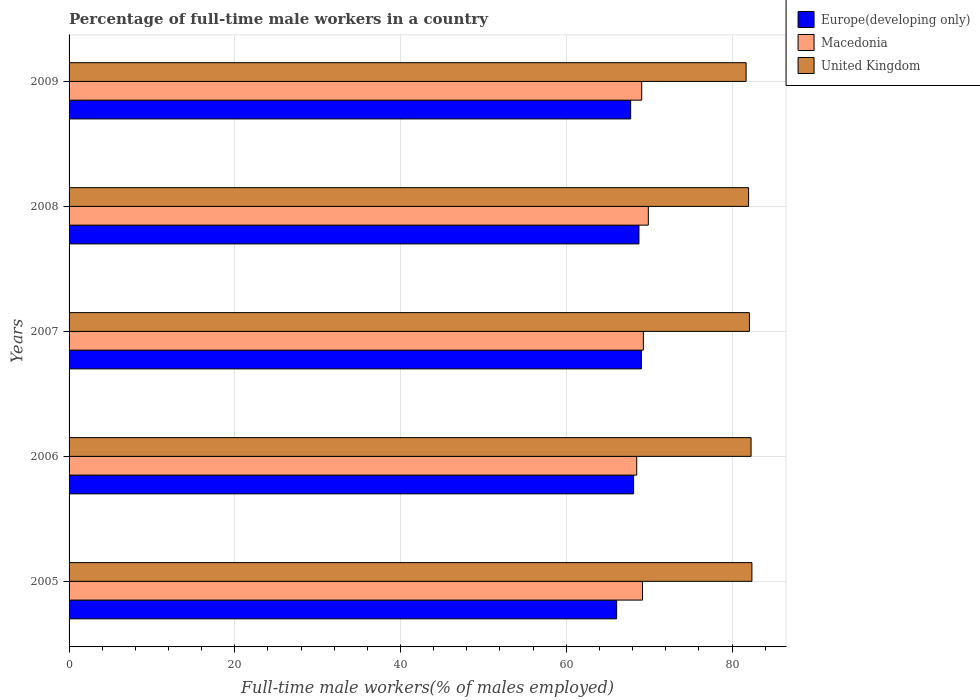How many groups of bars are there?
Provide a succinct answer. 5. Are the number of bars per tick equal to the number of legend labels?
Provide a short and direct response. Yes. What is the label of the 5th group of bars from the top?
Your answer should be very brief. 2005. What is the percentage of full-time male workers in United Kingdom in 2006?
Keep it short and to the point. 82.3. Across all years, what is the maximum percentage of full-time male workers in Macedonia?
Your answer should be compact. 69.9. Across all years, what is the minimum percentage of full-time male workers in Macedonia?
Keep it short and to the point. 68.5. In which year was the percentage of full-time male workers in Macedonia minimum?
Ensure brevity in your answer.  2006. What is the total percentage of full-time male workers in United Kingdom in the graph?
Provide a succinct answer. 410.5. What is the difference between the percentage of full-time male workers in Europe(developing only) in 2006 and that in 2007?
Keep it short and to the point. -0.93. What is the difference between the percentage of full-time male workers in Europe(developing only) in 2005 and the percentage of full-time male workers in Macedonia in 2008?
Offer a very short reply. -3.82. What is the average percentage of full-time male workers in United Kingdom per year?
Give a very brief answer. 82.1. In the year 2007, what is the difference between the percentage of full-time male workers in Macedonia and percentage of full-time male workers in Europe(developing only)?
Ensure brevity in your answer.  0.24. What is the ratio of the percentage of full-time male workers in United Kingdom in 2007 to that in 2009?
Offer a terse response. 1. Is the difference between the percentage of full-time male workers in Macedonia in 2007 and 2009 greater than the difference between the percentage of full-time male workers in Europe(developing only) in 2007 and 2009?
Provide a short and direct response. No. What is the difference between the highest and the second highest percentage of full-time male workers in Macedonia?
Your answer should be compact. 0.6. What is the difference between the highest and the lowest percentage of full-time male workers in Europe(developing only)?
Provide a succinct answer. 2.98. Is the sum of the percentage of full-time male workers in Europe(developing only) in 2006 and 2009 greater than the maximum percentage of full-time male workers in Macedonia across all years?
Make the answer very short. Yes. What does the 2nd bar from the top in 2006 represents?
Provide a succinct answer. Macedonia. What does the 3rd bar from the bottom in 2009 represents?
Ensure brevity in your answer.  United Kingdom. How many bars are there?
Offer a terse response. 15. Are all the bars in the graph horizontal?
Your answer should be compact. Yes. What is the difference between two consecutive major ticks on the X-axis?
Provide a succinct answer. 20. Does the graph contain grids?
Provide a short and direct response. Yes. Where does the legend appear in the graph?
Keep it short and to the point. Top right. How are the legend labels stacked?
Provide a short and direct response. Vertical. What is the title of the graph?
Make the answer very short. Percentage of full-time male workers in a country. Does "Vanuatu" appear as one of the legend labels in the graph?
Keep it short and to the point. No. What is the label or title of the X-axis?
Make the answer very short. Full-time male workers(% of males employed). What is the Full-time male workers(% of males employed) of Europe(developing only) in 2005?
Give a very brief answer. 66.08. What is the Full-time male workers(% of males employed) of Macedonia in 2005?
Offer a very short reply. 69.2. What is the Full-time male workers(% of males employed) of United Kingdom in 2005?
Keep it short and to the point. 82.4. What is the Full-time male workers(% of males employed) in Europe(developing only) in 2006?
Keep it short and to the point. 68.12. What is the Full-time male workers(% of males employed) of Macedonia in 2006?
Keep it short and to the point. 68.5. What is the Full-time male workers(% of males employed) of United Kingdom in 2006?
Your response must be concise. 82.3. What is the Full-time male workers(% of males employed) in Europe(developing only) in 2007?
Offer a very short reply. 69.06. What is the Full-time male workers(% of males employed) of Macedonia in 2007?
Make the answer very short. 69.3. What is the Full-time male workers(% of males employed) in United Kingdom in 2007?
Offer a terse response. 82.1. What is the Full-time male workers(% of males employed) in Europe(developing only) in 2008?
Give a very brief answer. 68.77. What is the Full-time male workers(% of males employed) of Macedonia in 2008?
Provide a short and direct response. 69.9. What is the Full-time male workers(% of males employed) in United Kingdom in 2008?
Keep it short and to the point. 82. What is the Full-time male workers(% of males employed) of Europe(developing only) in 2009?
Provide a short and direct response. 67.77. What is the Full-time male workers(% of males employed) in Macedonia in 2009?
Your answer should be very brief. 69.1. What is the Full-time male workers(% of males employed) in United Kingdom in 2009?
Your answer should be compact. 81.7. Across all years, what is the maximum Full-time male workers(% of males employed) in Europe(developing only)?
Give a very brief answer. 69.06. Across all years, what is the maximum Full-time male workers(% of males employed) of Macedonia?
Ensure brevity in your answer.  69.9. Across all years, what is the maximum Full-time male workers(% of males employed) of United Kingdom?
Provide a succinct answer. 82.4. Across all years, what is the minimum Full-time male workers(% of males employed) in Europe(developing only)?
Keep it short and to the point. 66.08. Across all years, what is the minimum Full-time male workers(% of males employed) of Macedonia?
Your response must be concise. 68.5. Across all years, what is the minimum Full-time male workers(% of males employed) of United Kingdom?
Offer a very short reply. 81.7. What is the total Full-time male workers(% of males employed) of Europe(developing only) in the graph?
Offer a very short reply. 339.8. What is the total Full-time male workers(% of males employed) in Macedonia in the graph?
Ensure brevity in your answer.  346. What is the total Full-time male workers(% of males employed) of United Kingdom in the graph?
Offer a terse response. 410.5. What is the difference between the Full-time male workers(% of males employed) in Europe(developing only) in 2005 and that in 2006?
Provide a short and direct response. -2.05. What is the difference between the Full-time male workers(% of males employed) in Europe(developing only) in 2005 and that in 2007?
Make the answer very short. -2.98. What is the difference between the Full-time male workers(% of males employed) of Macedonia in 2005 and that in 2007?
Your answer should be very brief. -0.1. What is the difference between the Full-time male workers(% of males employed) of Europe(developing only) in 2005 and that in 2008?
Keep it short and to the point. -2.69. What is the difference between the Full-time male workers(% of males employed) of United Kingdom in 2005 and that in 2008?
Give a very brief answer. 0.4. What is the difference between the Full-time male workers(% of males employed) of Europe(developing only) in 2005 and that in 2009?
Provide a short and direct response. -1.69. What is the difference between the Full-time male workers(% of males employed) in Europe(developing only) in 2006 and that in 2007?
Make the answer very short. -0.93. What is the difference between the Full-time male workers(% of males employed) in Macedonia in 2006 and that in 2007?
Offer a terse response. -0.8. What is the difference between the Full-time male workers(% of males employed) in Europe(developing only) in 2006 and that in 2008?
Your answer should be compact. -0.64. What is the difference between the Full-time male workers(% of males employed) in Europe(developing only) in 2006 and that in 2009?
Offer a terse response. 0.36. What is the difference between the Full-time male workers(% of males employed) of Macedonia in 2006 and that in 2009?
Provide a short and direct response. -0.6. What is the difference between the Full-time male workers(% of males employed) of Europe(developing only) in 2007 and that in 2008?
Offer a very short reply. 0.29. What is the difference between the Full-time male workers(% of males employed) of United Kingdom in 2007 and that in 2008?
Keep it short and to the point. 0.1. What is the difference between the Full-time male workers(% of males employed) in Europe(developing only) in 2007 and that in 2009?
Ensure brevity in your answer.  1.29. What is the difference between the Full-time male workers(% of males employed) in Macedonia in 2007 and that in 2009?
Your answer should be very brief. 0.2. What is the difference between the Full-time male workers(% of males employed) in Europe(developing only) in 2005 and the Full-time male workers(% of males employed) in Macedonia in 2006?
Your answer should be compact. -2.42. What is the difference between the Full-time male workers(% of males employed) in Europe(developing only) in 2005 and the Full-time male workers(% of males employed) in United Kingdom in 2006?
Ensure brevity in your answer.  -16.22. What is the difference between the Full-time male workers(% of males employed) in Macedonia in 2005 and the Full-time male workers(% of males employed) in United Kingdom in 2006?
Give a very brief answer. -13.1. What is the difference between the Full-time male workers(% of males employed) in Europe(developing only) in 2005 and the Full-time male workers(% of males employed) in Macedonia in 2007?
Provide a succinct answer. -3.22. What is the difference between the Full-time male workers(% of males employed) of Europe(developing only) in 2005 and the Full-time male workers(% of males employed) of United Kingdom in 2007?
Offer a very short reply. -16.02. What is the difference between the Full-time male workers(% of males employed) in Europe(developing only) in 2005 and the Full-time male workers(% of males employed) in Macedonia in 2008?
Make the answer very short. -3.82. What is the difference between the Full-time male workers(% of males employed) in Europe(developing only) in 2005 and the Full-time male workers(% of males employed) in United Kingdom in 2008?
Provide a succinct answer. -15.92. What is the difference between the Full-time male workers(% of males employed) in Macedonia in 2005 and the Full-time male workers(% of males employed) in United Kingdom in 2008?
Make the answer very short. -12.8. What is the difference between the Full-time male workers(% of males employed) of Europe(developing only) in 2005 and the Full-time male workers(% of males employed) of Macedonia in 2009?
Offer a very short reply. -3.02. What is the difference between the Full-time male workers(% of males employed) of Europe(developing only) in 2005 and the Full-time male workers(% of males employed) of United Kingdom in 2009?
Provide a succinct answer. -15.62. What is the difference between the Full-time male workers(% of males employed) of Macedonia in 2005 and the Full-time male workers(% of males employed) of United Kingdom in 2009?
Make the answer very short. -12.5. What is the difference between the Full-time male workers(% of males employed) in Europe(developing only) in 2006 and the Full-time male workers(% of males employed) in Macedonia in 2007?
Provide a succinct answer. -1.18. What is the difference between the Full-time male workers(% of males employed) of Europe(developing only) in 2006 and the Full-time male workers(% of males employed) of United Kingdom in 2007?
Offer a very short reply. -13.98. What is the difference between the Full-time male workers(% of males employed) in Europe(developing only) in 2006 and the Full-time male workers(% of males employed) in Macedonia in 2008?
Provide a short and direct response. -1.78. What is the difference between the Full-time male workers(% of males employed) of Europe(developing only) in 2006 and the Full-time male workers(% of males employed) of United Kingdom in 2008?
Keep it short and to the point. -13.88. What is the difference between the Full-time male workers(% of males employed) in Macedonia in 2006 and the Full-time male workers(% of males employed) in United Kingdom in 2008?
Offer a terse response. -13.5. What is the difference between the Full-time male workers(% of males employed) of Europe(developing only) in 2006 and the Full-time male workers(% of males employed) of Macedonia in 2009?
Give a very brief answer. -0.98. What is the difference between the Full-time male workers(% of males employed) in Europe(developing only) in 2006 and the Full-time male workers(% of males employed) in United Kingdom in 2009?
Provide a succinct answer. -13.58. What is the difference between the Full-time male workers(% of males employed) in Europe(developing only) in 2007 and the Full-time male workers(% of males employed) in Macedonia in 2008?
Provide a succinct answer. -0.84. What is the difference between the Full-time male workers(% of males employed) in Europe(developing only) in 2007 and the Full-time male workers(% of males employed) in United Kingdom in 2008?
Provide a succinct answer. -12.94. What is the difference between the Full-time male workers(% of males employed) in Macedonia in 2007 and the Full-time male workers(% of males employed) in United Kingdom in 2008?
Your answer should be compact. -12.7. What is the difference between the Full-time male workers(% of males employed) of Europe(developing only) in 2007 and the Full-time male workers(% of males employed) of Macedonia in 2009?
Provide a short and direct response. -0.04. What is the difference between the Full-time male workers(% of males employed) of Europe(developing only) in 2007 and the Full-time male workers(% of males employed) of United Kingdom in 2009?
Offer a very short reply. -12.64. What is the difference between the Full-time male workers(% of males employed) of Europe(developing only) in 2008 and the Full-time male workers(% of males employed) of Macedonia in 2009?
Keep it short and to the point. -0.33. What is the difference between the Full-time male workers(% of males employed) in Europe(developing only) in 2008 and the Full-time male workers(% of males employed) in United Kingdom in 2009?
Provide a short and direct response. -12.93. What is the difference between the Full-time male workers(% of males employed) of Macedonia in 2008 and the Full-time male workers(% of males employed) of United Kingdom in 2009?
Ensure brevity in your answer.  -11.8. What is the average Full-time male workers(% of males employed) of Europe(developing only) per year?
Provide a short and direct response. 67.96. What is the average Full-time male workers(% of males employed) in Macedonia per year?
Keep it short and to the point. 69.2. What is the average Full-time male workers(% of males employed) in United Kingdom per year?
Ensure brevity in your answer.  82.1. In the year 2005, what is the difference between the Full-time male workers(% of males employed) in Europe(developing only) and Full-time male workers(% of males employed) in Macedonia?
Give a very brief answer. -3.12. In the year 2005, what is the difference between the Full-time male workers(% of males employed) in Europe(developing only) and Full-time male workers(% of males employed) in United Kingdom?
Offer a terse response. -16.32. In the year 2005, what is the difference between the Full-time male workers(% of males employed) of Macedonia and Full-time male workers(% of males employed) of United Kingdom?
Your answer should be very brief. -13.2. In the year 2006, what is the difference between the Full-time male workers(% of males employed) of Europe(developing only) and Full-time male workers(% of males employed) of Macedonia?
Your answer should be very brief. -0.38. In the year 2006, what is the difference between the Full-time male workers(% of males employed) in Europe(developing only) and Full-time male workers(% of males employed) in United Kingdom?
Offer a very short reply. -14.18. In the year 2007, what is the difference between the Full-time male workers(% of males employed) in Europe(developing only) and Full-time male workers(% of males employed) in Macedonia?
Make the answer very short. -0.24. In the year 2007, what is the difference between the Full-time male workers(% of males employed) of Europe(developing only) and Full-time male workers(% of males employed) of United Kingdom?
Your answer should be very brief. -13.04. In the year 2008, what is the difference between the Full-time male workers(% of males employed) in Europe(developing only) and Full-time male workers(% of males employed) in Macedonia?
Give a very brief answer. -1.13. In the year 2008, what is the difference between the Full-time male workers(% of males employed) in Europe(developing only) and Full-time male workers(% of males employed) in United Kingdom?
Your response must be concise. -13.23. In the year 2008, what is the difference between the Full-time male workers(% of males employed) of Macedonia and Full-time male workers(% of males employed) of United Kingdom?
Your response must be concise. -12.1. In the year 2009, what is the difference between the Full-time male workers(% of males employed) of Europe(developing only) and Full-time male workers(% of males employed) of Macedonia?
Keep it short and to the point. -1.33. In the year 2009, what is the difference between the Full-time male workers(% of males employed) of Europe(developing only) and Full-time male workers(% of males employed) of United Kingdom?
Your answer should be compact. -13.93. In the year 2009, what is the difference between the Full-time male workers(% of males employed) of Macedonia and Full-time male workers(% of males employed) of United Kingdom?
Provide a succinct answer. -12.6. What is the ratio of the Full-time male workers(% of males employed) in Europe(developing only) in 2005 to that in 2006?
Offer a very short reply. 0.97. What is the ratio of the Full-time male workers(% of males employed) of Macedonia in 2005 to that in 2006?
Offer a terse response. 1.01. What is the ratio of the Full-time male workers(% of males employed) of United Kingdom in 2005 to that in 2006?
Your answer should be compact. 1. What is the ratio of the Full-time male workers(% of males employed) in Europe(developing only) in 2005 to that in 2007?
Your response must be concise. 0.96. What is the ratio of the Full-time male workers(% of males employed) of Macedonia in 2005 to that in 2007?
Keep it short and to the point. 1. What is the ratio of the Full-time male workers(% of males employed) in Europe(developing only) in 2005 to that in 2008?
Provide a short and direct response. 0.96. What is the ratio of the Full-time male workers(% of males employed) of Macedonia in 2005 to that in 2008?
Your answer should be very brief. 0.99. What is the ratio of the Full-time male workers(% of males employed) in Europe(developing only) in 2005 to that in 2009?
Offer a very short reply. 0.98. What is the ratio of the Full-time male workers(% of males employed) in Macedonia in 2005 to that in 2009?
Offer a terse response. 1. What is the ratio of the Full-time male workers(% of males employed) in United Kingdom in 2005 to that in 2009?
Offer a terse response. 1.01. What is the ratio of the Full-time male workers(% of males employed) in Europe(developing only) in 2006 to that in 2007?
Provide a short and direct response. 0.99. What is the ratio of the Full-time male workers(% of males employed) of Europe(developing only) in 2006 to that in 2008?
Keep it short and to the point. 0.99. What is the ratio of the Full-time male workers(% of males employed) of Macedonia in 2006 to that in 2008?
Ensure brevity in your answer.  0.98. What is the ratio of the Full-time male workers(% of males employed) in United Kingdom in 2006 to that in 2009?
Give a very brief answer. 1.01. What is the ratio of the Full-time male workers(% of males employed) of Europe(developing only) in 2007 to that in 2008?
Your answer should be very brief. 1. What is the ratio of the Full-time male workers(% of males employed) in Macedonia in 2007 to that in 2008?
Keep it short and to the point. 0.99. What is the ratio of the Full-time male workers(% of males employed) in Europe(developing only) in 2007 to that in 2009?
Offer a terse response. 1.02. What is the ratio of the Full-time male workers(% of males employed) in United Kingdom in 2007 to that in 2009?
Offer a very short reply. 1. What is the ratio of the Full-time male workers(% of males employed) of Europe(developing only) in 2008 to that in 2009?
Keep it short and to the point. 1.01. What is the ratio of the Full-time male workers(% of males employed) in Macedonia in 2008 to that in 2009?
Give a very brief answer. 1.01. What is the ratio of the Full-time male workers(% of males employed) of United Kingdom in 2008 to that in 2009?
Your answer should be very brief. 1. What is the difference between the highest and the second highest Full-time male workers(% of males employed) in Europe(developing only)?
Provide a succinct answer. 0.29. What is the difference between the highest and the second highest Full-time male workers(% of males employed) in United Kingdom?
Offer a very short reply. 0.1. What is the difference between the highest and the lowest Full-time male workers(% of males employed) of Europe(developing only)?
Offer a terse response. 2.98. 